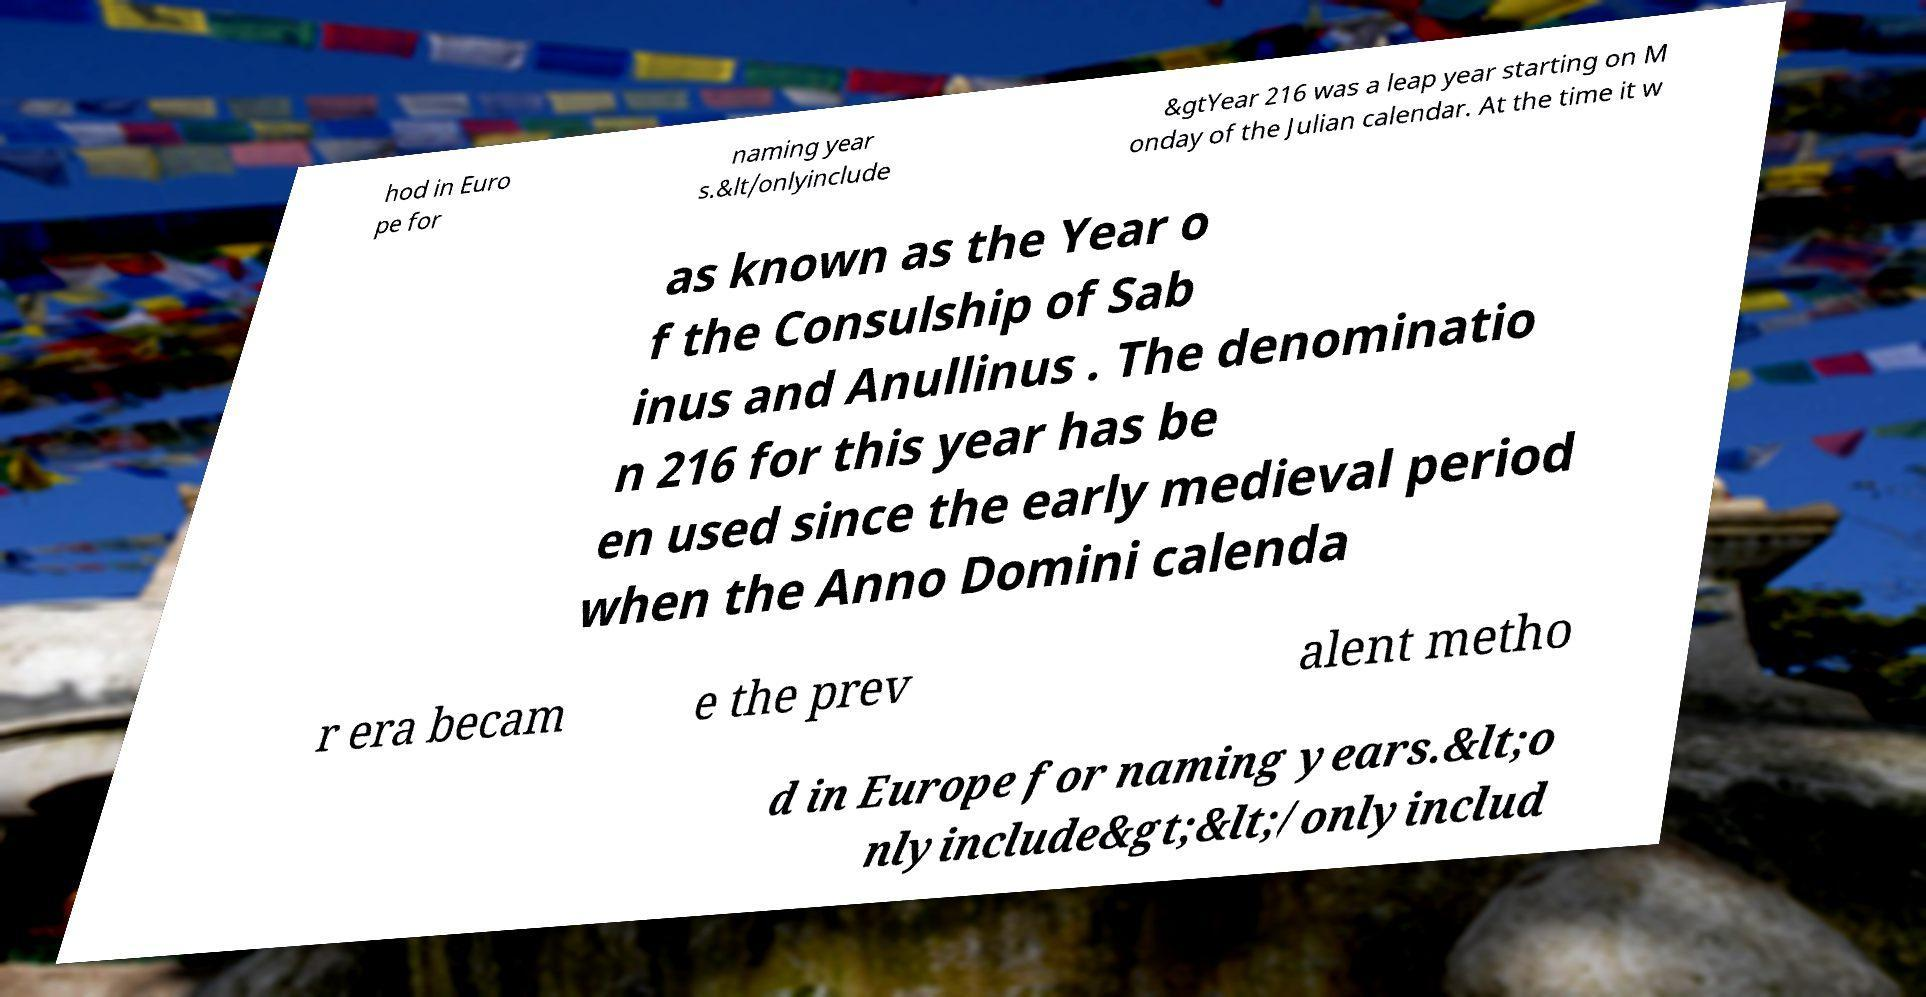Can you read and provide the text displayed in the image?This photo seems to have some interesting text. Can you extract and type it out for me? hod in Euro pe for naming year s.&lt/onlyinclude &gtYear 216 was a leap year starting on M onday of the Julian calendar. At the time it w as known as the Year o f the Consulship of Sab inus and Anullinus . The denominatio n 216 for this year has be en used since the early medieval period when the Anno Domini calenda r era becam e the prev alent metho d in Europe for naming years.&lt;o nlyinclude&gt;&lt;/onlyinclud 